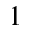Convert formula to latex. <formula><loc_0><loc_0><loc_500><loc_500>^ { 1 }</formula> 